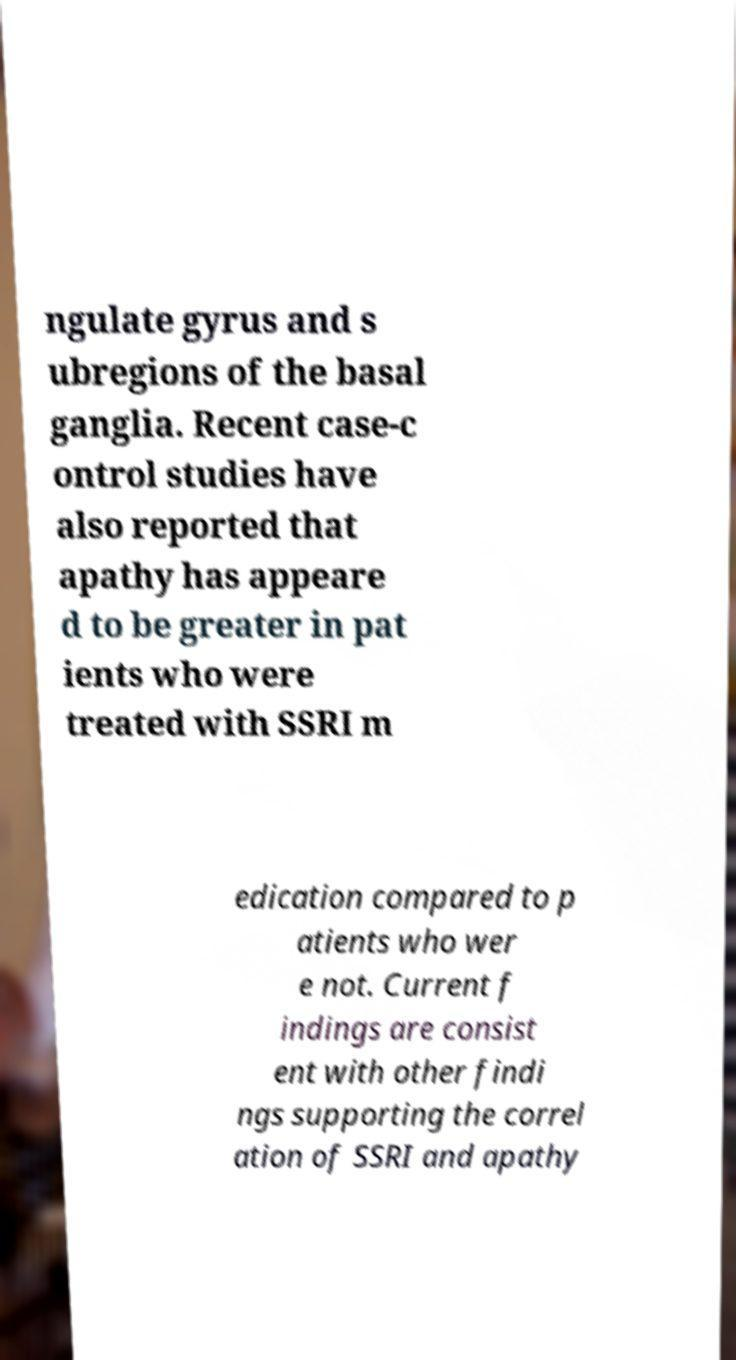There's text embedded in this image that I need extracted. Can you transcribe it verbatim? ngulate gyrus and s ubregions of the basal ganglia. Recent case-c ontrol studies have also reported that apathy has appeare d to be greater in pat ients who were treated with SSRI m edication compared to p atients who wer e not. Current f indings are consist ent with other findi ngs supporting the correl ation of SSRI and apathy 